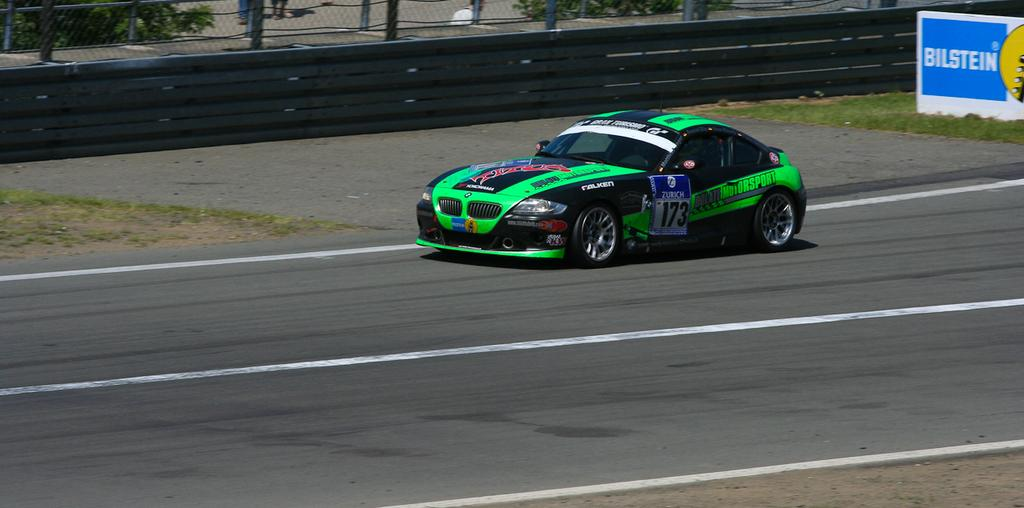What is the main subject of the image? There is a vehicle on the road in the image. What can be seen in the background of the image? In the background of the image, there is a railing, grass, a hoarding, a mesh, and leaves. Can you describe the hoarding in the background? Unfortunately, the facts provided do not give any details about the hoarding. What type of vegetation is present in the background of the image? Grass and leaves are present in the background of the image. How many pizzas are hanging from the mesh in the background of the image? There are no pizzas present in the image, and therefore no such activity can be observed. 